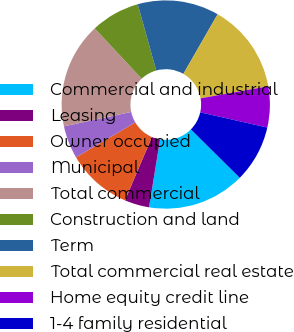Convert chart to OTSL. <chart><loc_0><loc_0><loc_500><loc_500><pie_chart><fcel>Commercial and industrial<fcel>Leasing<fcel>Owner occupied<fcel>Municipal<fcel>Total commercial<fcel>Construction and land<fcel>Term<fcel>Total commercial real estate<fcel>Home equity credit line<fcel>1-4 family residential<nl><fcel>15.15%<fcel>3.84%<fcel>10.13%<fcel>5.1%<fcel>16.41%<fcel>7.61%<fcel>12.64%<fcel>13.9%<fcel>6.35%<fcel>8.87%<nl></chart> 